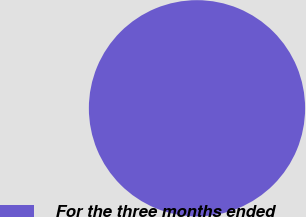Convert chart. <chart><loc_0><loc_0><loc_500><loc_500><pie_chart><fcel>For the three months ended<nl><fcel>100.0%<nl></chart> 